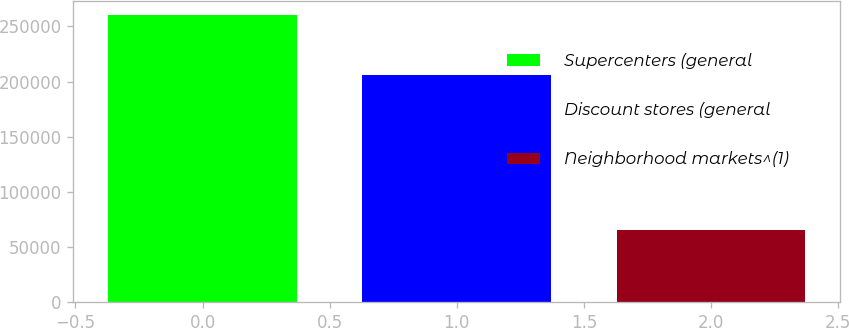<chart> <loc_0><loc_0><loc_500><loc_500><bar_chart><fcel>Supercenters (general<fcel>Discount stores (general<fcel>Neighborhood markets^(1)<nl><fcel>260000<fcel>206000<fcel>65000<nl></chart> 